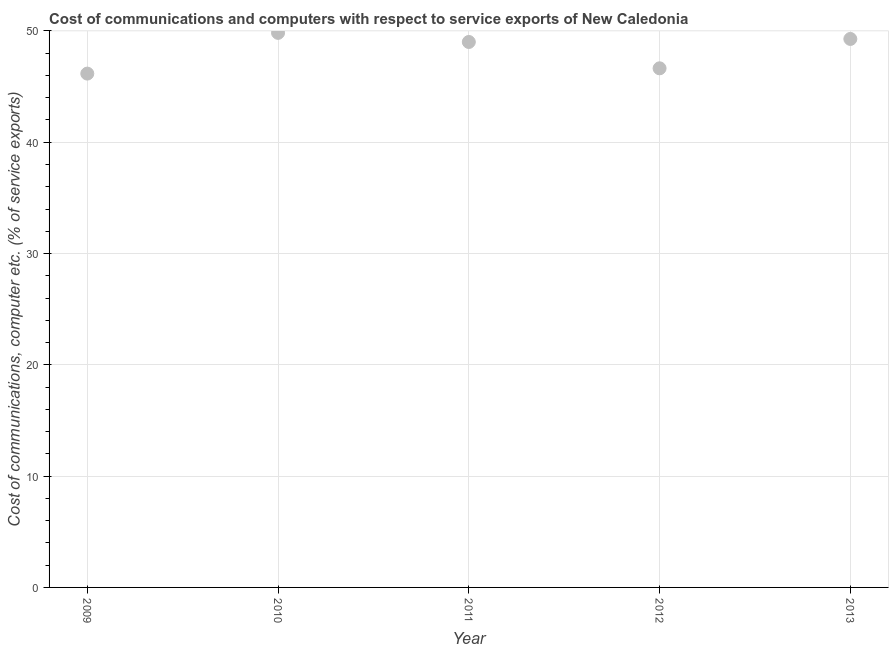What is the cost of communications and computer in 2013?
Offer a terse response. 49.28. Across all years, what is the maximum cost of communications and computer?
Provide a short and direct response. 49.83. Across all years, what is the minimum cost of communications and computer?
Give a very brief answer. 46.17. In which year was the cost of communications and computer minimum?
Give a very brief answer. 2009. What is the sum of the cost of communications and computer?
Give a very brief answer. 240.92. What is the difference between the cost of communications and computer in 2010 and 2012?
Offer a very short reply. 3.19. What is the average cost of communications and computer per year?
Make the answer very short. 48.18. What is the median cost of communications and computer?
Offer a very short reply. 49.01. In how many years, is the cost of communications and computer greater than 38 %?
Ensure brevity in your answer.  5. Do a majority of the years between 2012 and 2011 (inclusive) have cost of communications and computer greater than 22 %?
Ensure brevity in your answer.  No. What is the ratio of the cost of communications and computer in 2009 to that in 2010?
Your answer should be compact. 0.93. Is the cost of communications and computer in 2010 less than that in 2013?
Provide a succinct answer. No. What is the difference between the highest and the second highest cost of communications and computer?
Offer a very short reply. 0.55. What is the difference between the highest and the lowest cost of communications and computer?
Give a very brief answer. 3.66. Does the cost of communications and computer monotonically increase over the years?
Keep it short and to the point. No. How many years are there in the graph?
Give a very brief answer. 5. What is the difference between two consecutive major ticks on the Y-axis?
Make the answer very short. 10. Are the values on the major ticks of Y-axis written in scientific E-notation?
Ensure brevity in your answer.  No. Does the graph contain grids?
Keep it short and to the point. Yes. What is the title of the graph?
Your response must be concise. Cost of communications and computers with respect to service exports of New Caledonia. What is the label or title of the Y-axis?
Provide a short and direct response. Cost of communications, computer etc. (% of service exports). What is the Cost of communications, computer etc. (% of service exports) in 2009?
Give a very brief answer. 46.17. What is the Cost of communications, computer etc. (% of service exports) in 2010?
Your answer should be compact. 49.83. What is the Cost of communications, computer etc. (% of service exports) in 2011?
Ensure brevity in your answer.  49.01. What is the Cost of communications, computer etc. (% of service exports) in 2012?
Offer a terse response. 46.64. What is the Cost of communications, computer etc. (% of service exports) in 2013?
Your response must be concise. 49.28. What is the difference between the Cost of communications, computer etc. (% of service exports) in 2009 and 2010?
Keep it short and to the point. -3.66. What is the difference between the Cost of communications, computer etc. (% of service exports) in 2009 and 2011?
Provide a short and direct response. -2.84. What is the difference between the Cost of communications, computer etc. (% of service exports) in 2009 and 2012?
Provide a succinct answer. -0.48. What is the difference between the Cost of communications, computer etc. (% of service exports) in 2009 and 2013?
Make the answer very short. -3.11. What is the difference between the Cost of communications, computer etc. (% of service exports) in 2010 and 2011?
Ensure brevity in your answer.  0.82. What is the difference between the Cost of communications, computer etc. (% of service exports) in 2010 and 2012?
Keep it short and to the point. 3.19. What is the difference between the Cost of communications, computer etc. (% of service exports) in 2010 and 2013?
Offer a terse response. 0.55. What is the difference between the Cost of communications, computer etc. (% of service exports) in 2011 and 2012?
Your response must be concise. 2.37. What is the difference between the Cost of communications, computer etc. (% of service exports) in 2011 and 2013?
Keep it short and to the point. -0.27. What is the difference between the Cost of communications, computer etc. (% of service exports) in 2012 and 2013?
Your answer should be compact. -2.64. What is the ratio of the Cost of communications, computer etc. (% of service exports) in 2009 to that in 2010?
Your answer should be very brief. 0.93. What is the ratio of the Cost of communications, computer etc. (% of service exports) in 2009 to that in 2011?
Provide a short and direct response. 0.94. What is the ratio of the Cost of communications, computer etc. (% of service exports) in 2009 to that in 2013?
Provide a succinct answer. 0.94. What is the ratio of the Cost of communications, computer etc. (% of service exports) in 2010 to that in 2012?
Your response must be concise. 1.07. What is the ratio of the Cost of communications, computer etc. (% of service exports) in 2011 to that in 2012?
Give a very brief answer. 1.05. What is the ratio of the Cost of communications, computer etc. (% of service exports) in 2011 to that in 2013?
Your response must be concise. 0.99. What is the ratio of the Cost of communications, computer etc. (% of service exports) in 2012 to that in 2013?
Keep it short and to the point. 0.95. 